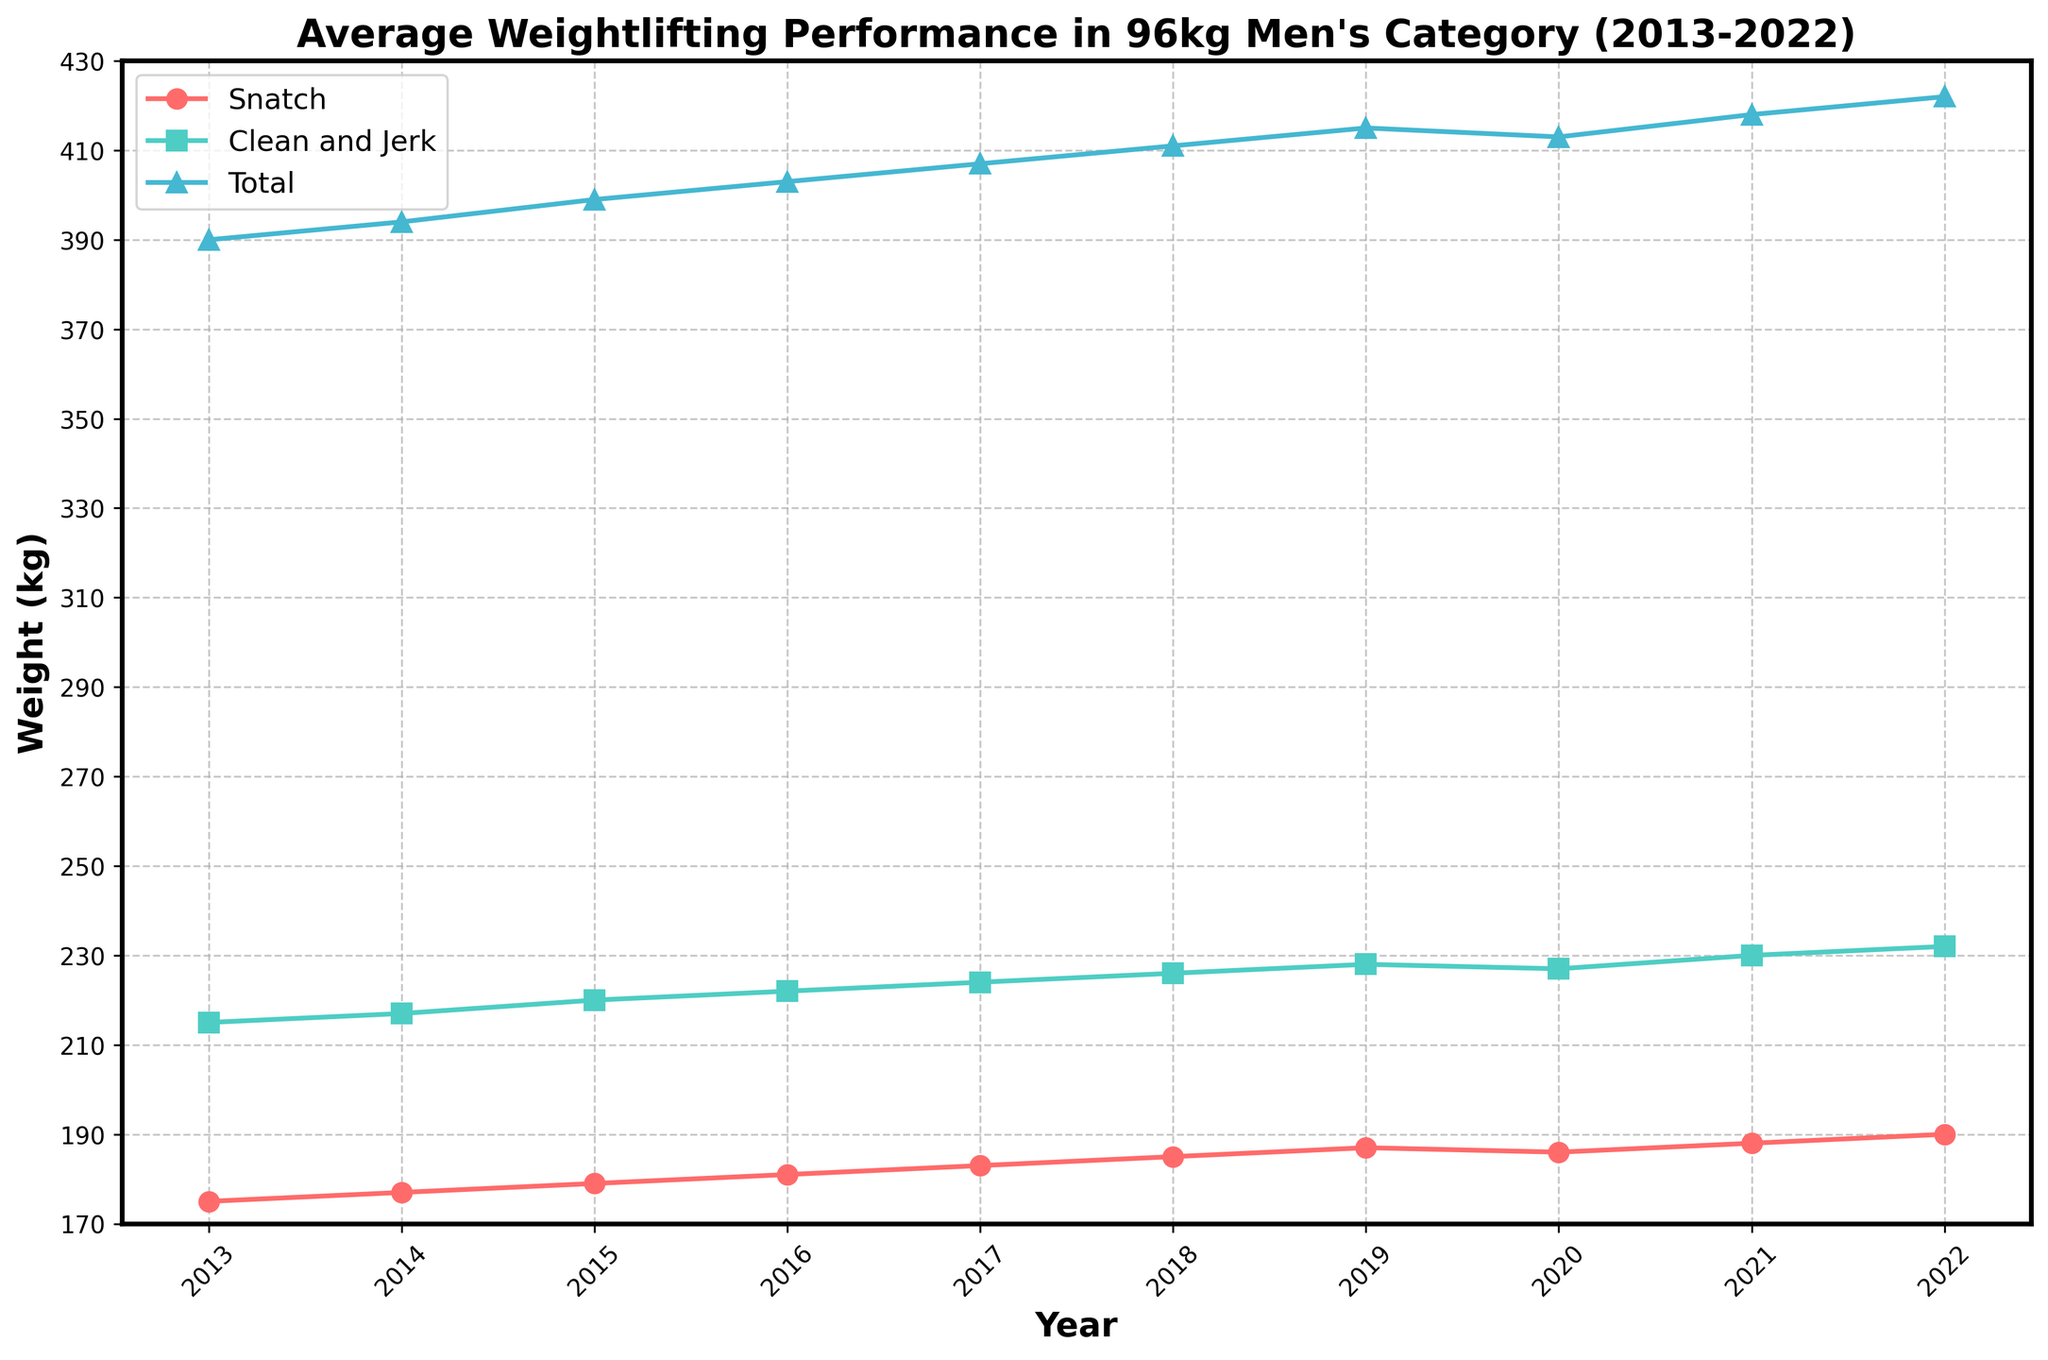What's the average Snatch weight in the first three years? Calculate the sum of the Snatch weights for the first three years (175 + 177 + 179) = 531. Divide by 3 to get the average, so 531 / 3 = 177
Answer: 177 Which lift had the greatest improvement over the decade? Compare the Snatch, Clean and Jerk, and Total lifts from 2013 to 2022. Snatch increased by 15 kg (190 - 175 = 15), Clean and Jerk by 17 kg (232 - 215 = 17), and Total by 32 kg (422 - 390 = 32). Thus, the Total had the greatest improvement
Answer: Total In which year did the Snatch and Clean and Jerk lifts both increase compared to the previous year? Analyze yearly changes for Snatch and Clean and Jerk. Both increased between 2013-2014, 2014-2015, 2015-2016, 2016-2017, 2017-2018, 2018-2019, 2020-2021, 2021-2022. Only the year 2020 shows a decrease in Snatch and Clean and Jerk
Answer: 2021 What's the Snatch weight halfway through the decade? Halfway through the decade is the fifth year, 2017. In 2017, the Snatch weight is 183 kg
Answer: 183 By how much did the Total weight increase from 2016 to 2022? Subtract the Total weight in 2016 from that in 2022: 422 - 403 = 19 kg
Answer: 19 Did the Clean and Jerk weight ever decrease? Check year-on-year changes. In 2020, the Clean and Jerk decreased from 228 kg to 227 kg
Answer: Yes In which year was the difference between Snatch and Clean and Jerk the smallest? Calculate the differences for each year and compare them. The smallest difference occurs in 2022: 232 - 190 = 42
Answer: 2022 What is the total increase in the Snatch weight over the decade? Subtract the Snatch weight in 2013 from that in 2022: 190 - 175 = 15 kg
Answer: 15 How many years did the Snatch weight increase continuously? The Snatch increased from 2013-2019 continuously (from 175 to 187). Then it decreased in 2020. Thus, it increased continuously for 7 years
Answer: 7 